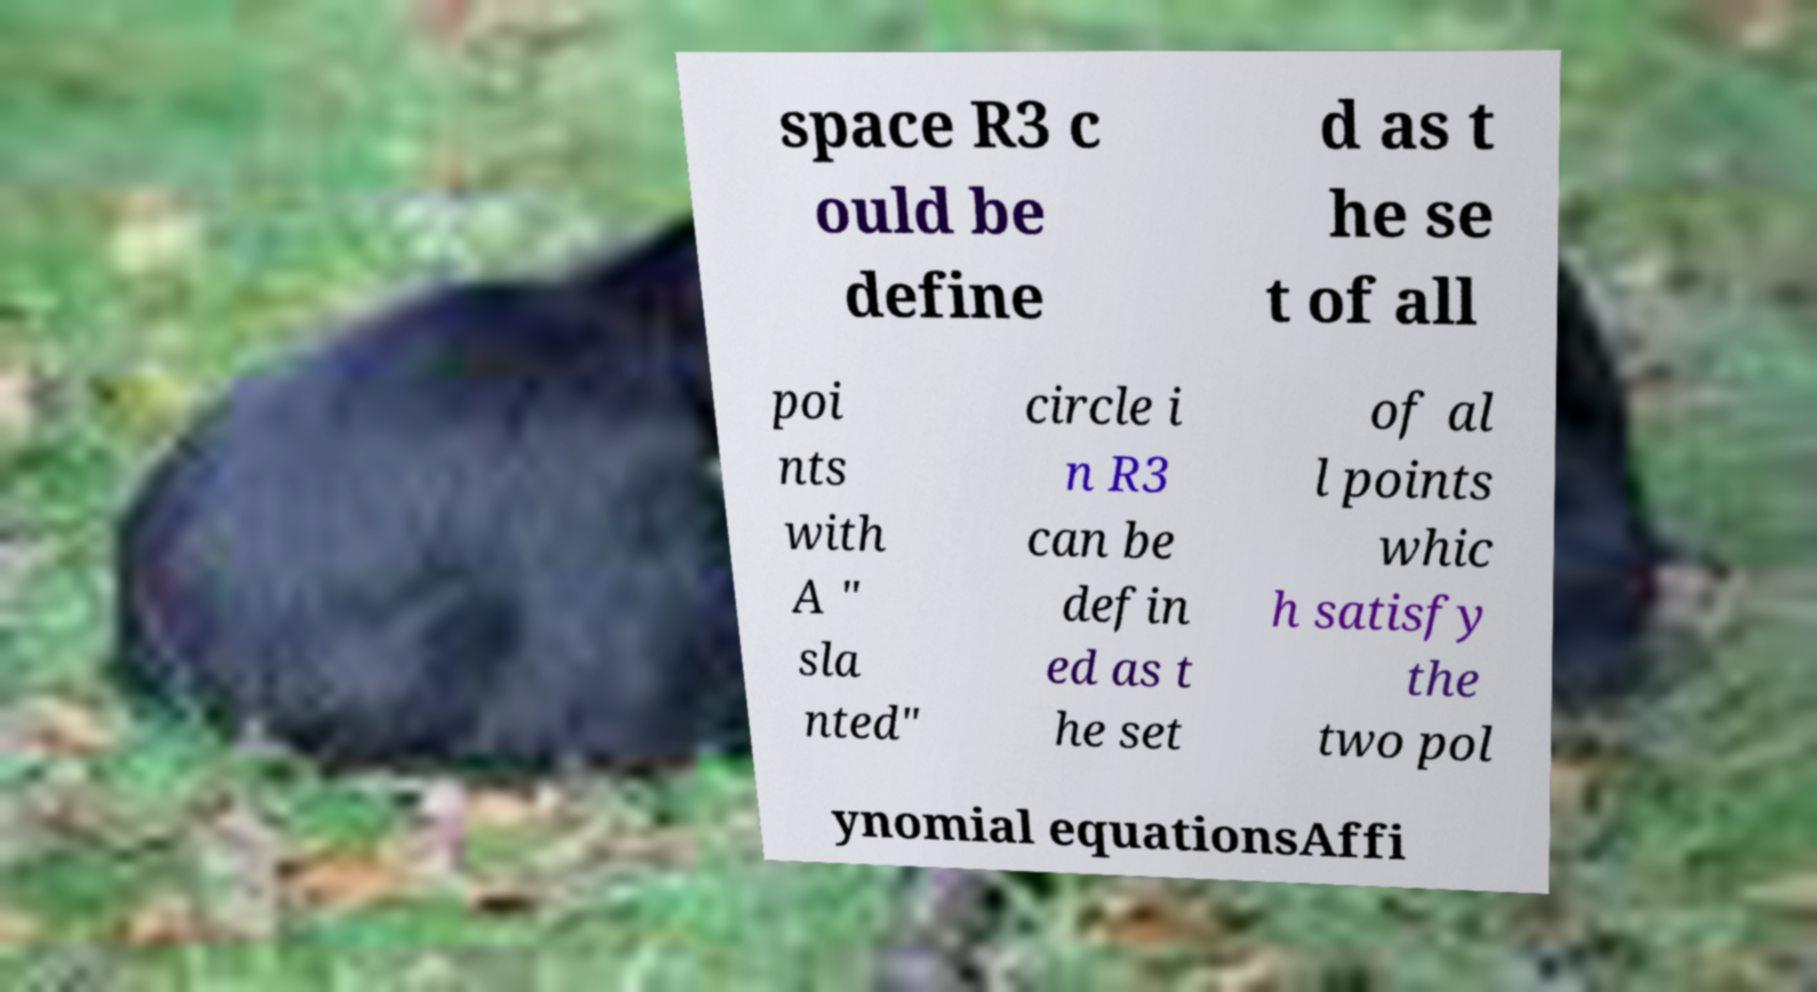What messages or text are displayed in this image? I need them in a readable, typed format. space R3 c ould be define d as t he se t of all poi nts with A " sla nted" circle i n R3 can be defin ed as t he set of al l points whic h satisfy the two pol ynomial equationsAffi 